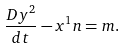<formula> <loc_0><loc_0><loc_500><loc_500>\frac { D y ^ { 2 } } { d t } - x ^ { 1 } n = m .</formula> 